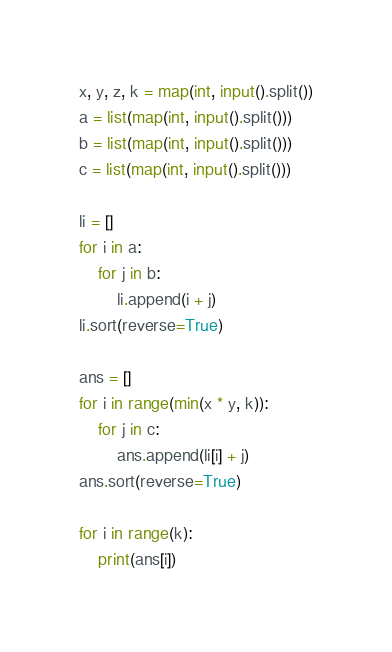<code> <loc_0><loc_0><loc_500><loc_500><_Python_>x, y, z, k = map(int, input().split())
a = list(map(int, input().split()))
b = list(map(int, input().split()))
c = list(map(int, input().split()))

li = []
for i in a:
    for j in b:
        li.append(i + j)
li.sort(reverse=True)

ans = []
for i in range(min(x * y, k)):
    for j in c:
        ans.append(li[i] + j)
ans.sort(reverse=True)

for i in range(k):
    print(ans[i])
</code> 